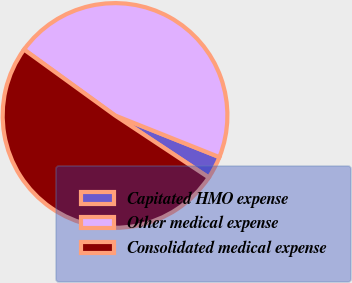Convert chart. <chart><loc_0><loc_0><loc_500><loc_500><pie_chart><fcel>Capitated HMO expense<fcel>Other medical expense<fcel>Consolidated medical expense<nl><fcel>3.26%<fcel>46.07%<fcel>50.67%<nl></chart> 